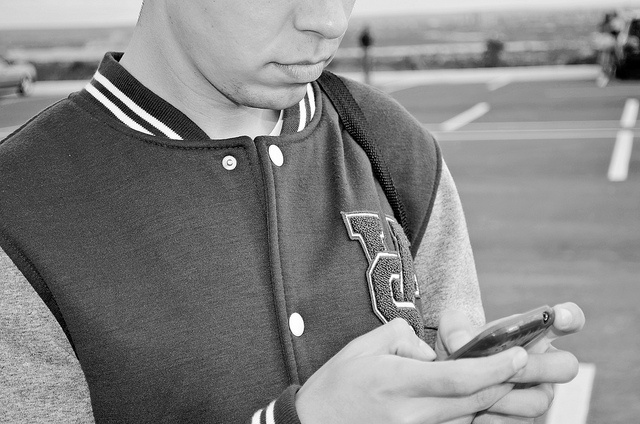Describe the objects in this image and their specific colors. I can see people in lightgray, gray, darkgray, and black tones, handbag in lightgray, black, gray, and darkgray tones, cell phone in lightgray, gray, darkgray, and black tones, car in lightgray, black, gray, darkgray, and silver tones, and car in lightgray, darkgray, gray, and black tones in this image. 